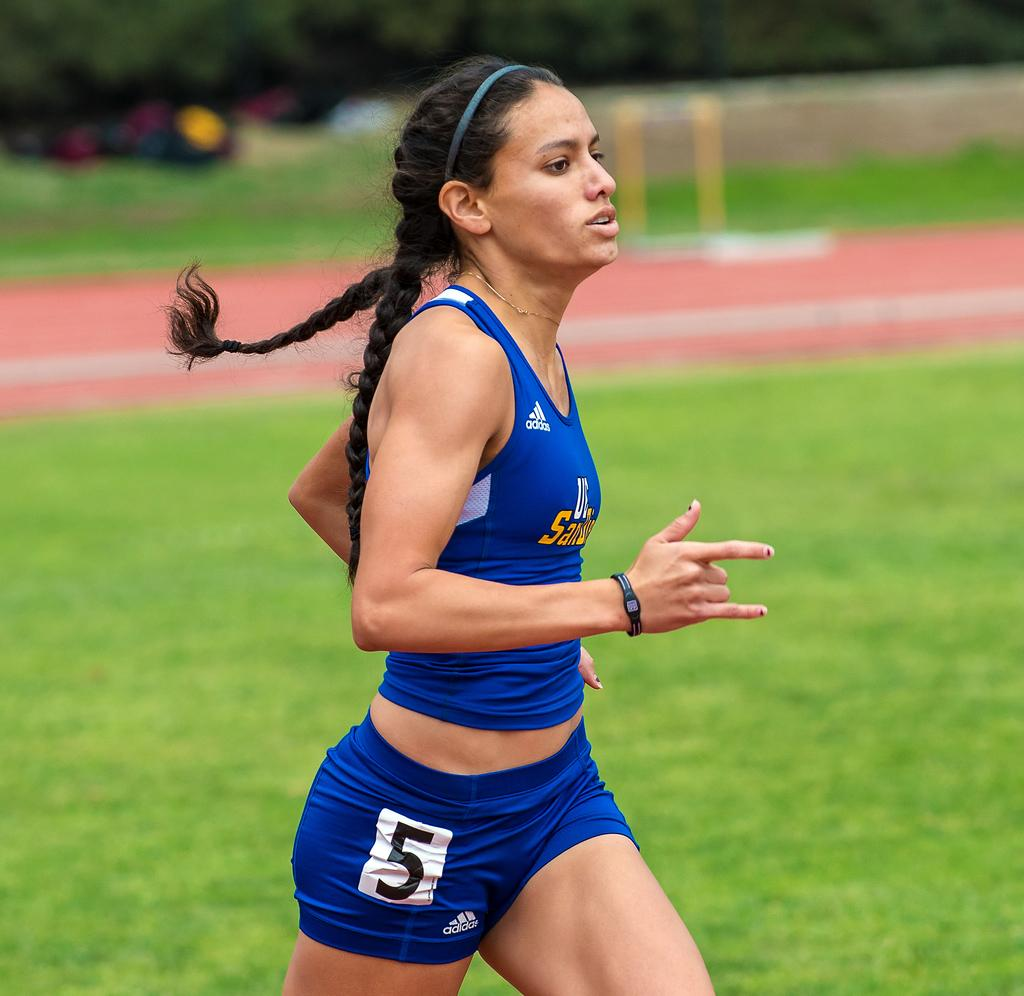<image>
Create a compact narrative representing the image presented. A woman is running wearing an Adidas shirt and shorts 